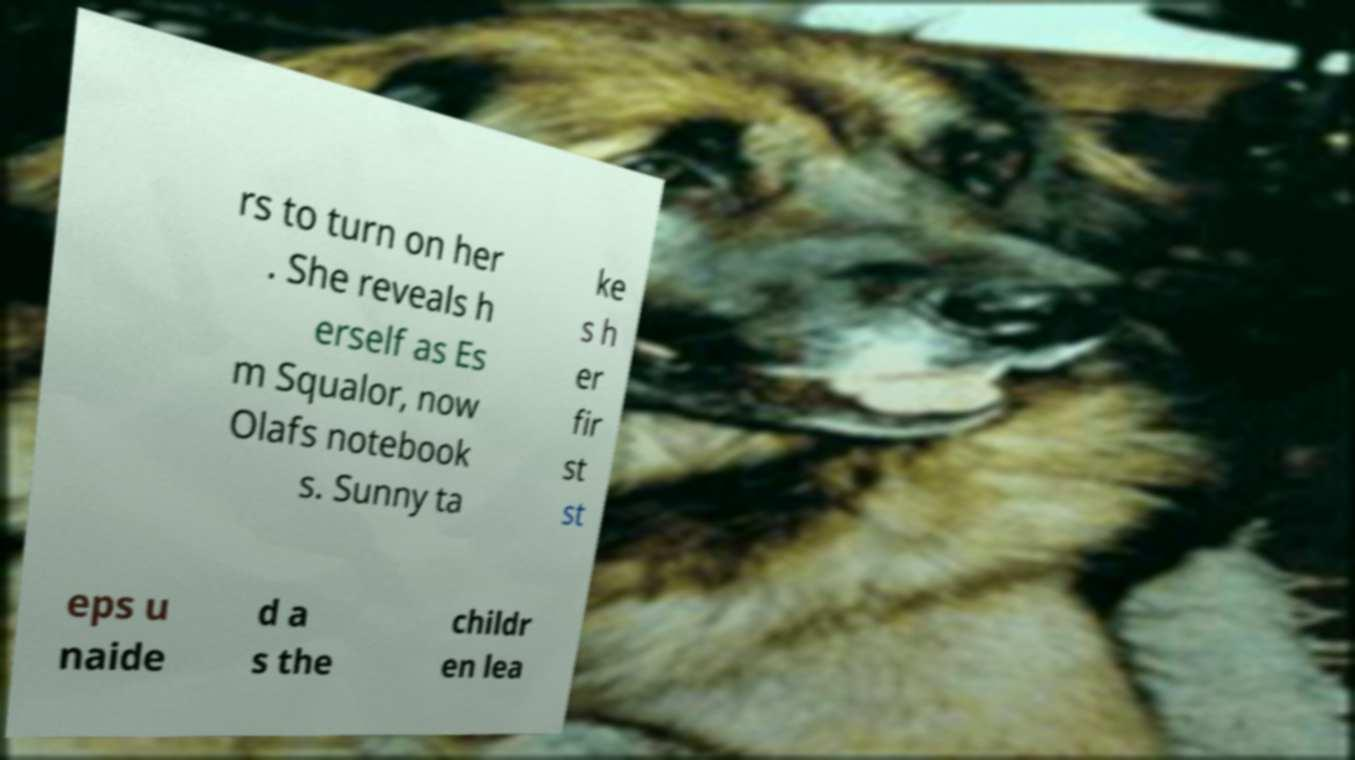Can you accurately transcribe the text from the provided image for me? rs to turn on her . She reveals h erself as Es m Squalor, now Olafs notebook s. Sunny ta ke s h er fir st st eps u naide d a s the childr en lea 